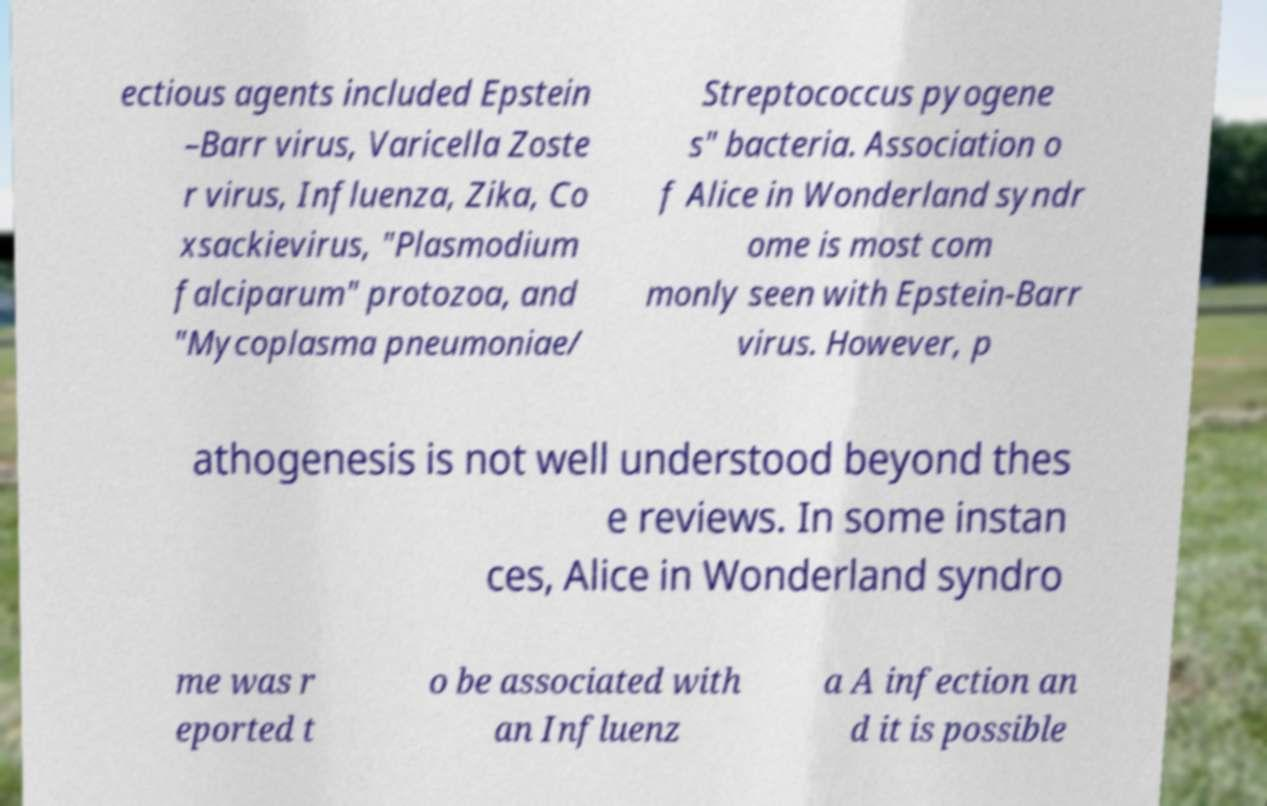Could you assist in decoding the text presented in this image and type it out clearly? ectious agents included Epstein –Barr virus, Varicella Zoste r virus, Influenza, Zika, Co xsackievirus, "Plasmodium falciparum" protozoa, and "Mycoplasma pneumoniae/ Streptococcus pyogene s" bacteria. Association o f Alice in Wonderland syndr ome is most com monly seen with Epstein-Barr virus. However, p athogenesis is not well understood beyond thes e reviews. In some instan ces, Alice in Wonderland syndro me was r eported t o be associated with an Influenz a A infection an d it is possible 